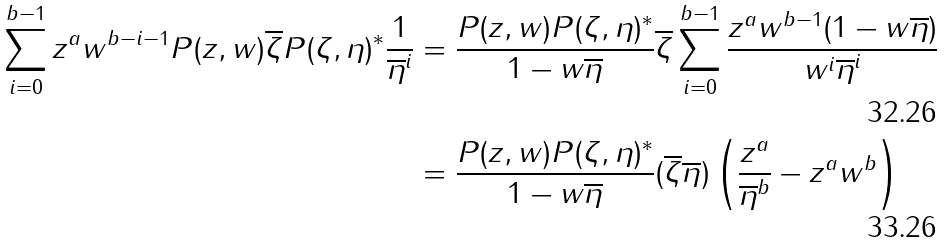Convert formula to latex. <formula><loc_0><loc_0><loc_500><loc_500>\sum _ { i = 0 } ^ { b - 1 } z ^ { a } w ^ { b - i - 1 } P ( z , w ) \overline { \zeta } P ( \zeta , \eta ) ^ { * } \frac { 1 } { \overline { \eta } ^ { i } } & = \frac { P ( z , w ) P ( \zeta , \eta ) ^ { * } } { 1 - w \overline { \eta } } \overline { \zeta } \sum _ { i = 0 } ^ { b - 1 } \frac { z ^ { a } w ^ { b - 1 } ( 1 - w \overline { \eta } ) } { w ^ { i } \overline { \eta } ^ { i } } \\ & = \frac { P ( z , w ) P ( \zeta , \eta ) ^ { * } } { 1 - w \overline { \eta } } ( \overline { \zeta } \overline { \eta } ) \left ( \frac { z ^ { a } } { \overline { \eta } ^ { b } } - z ^ { a } w ^ { b } \right )</formula> 